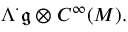Convert formula to latex. <formula><loc_0><loc_0><loc_500><loc_500>\Lambda ^ { \cdot } { \mathfrak { g } } \otimes C ^ { \infty } ( M ) .</formula> 